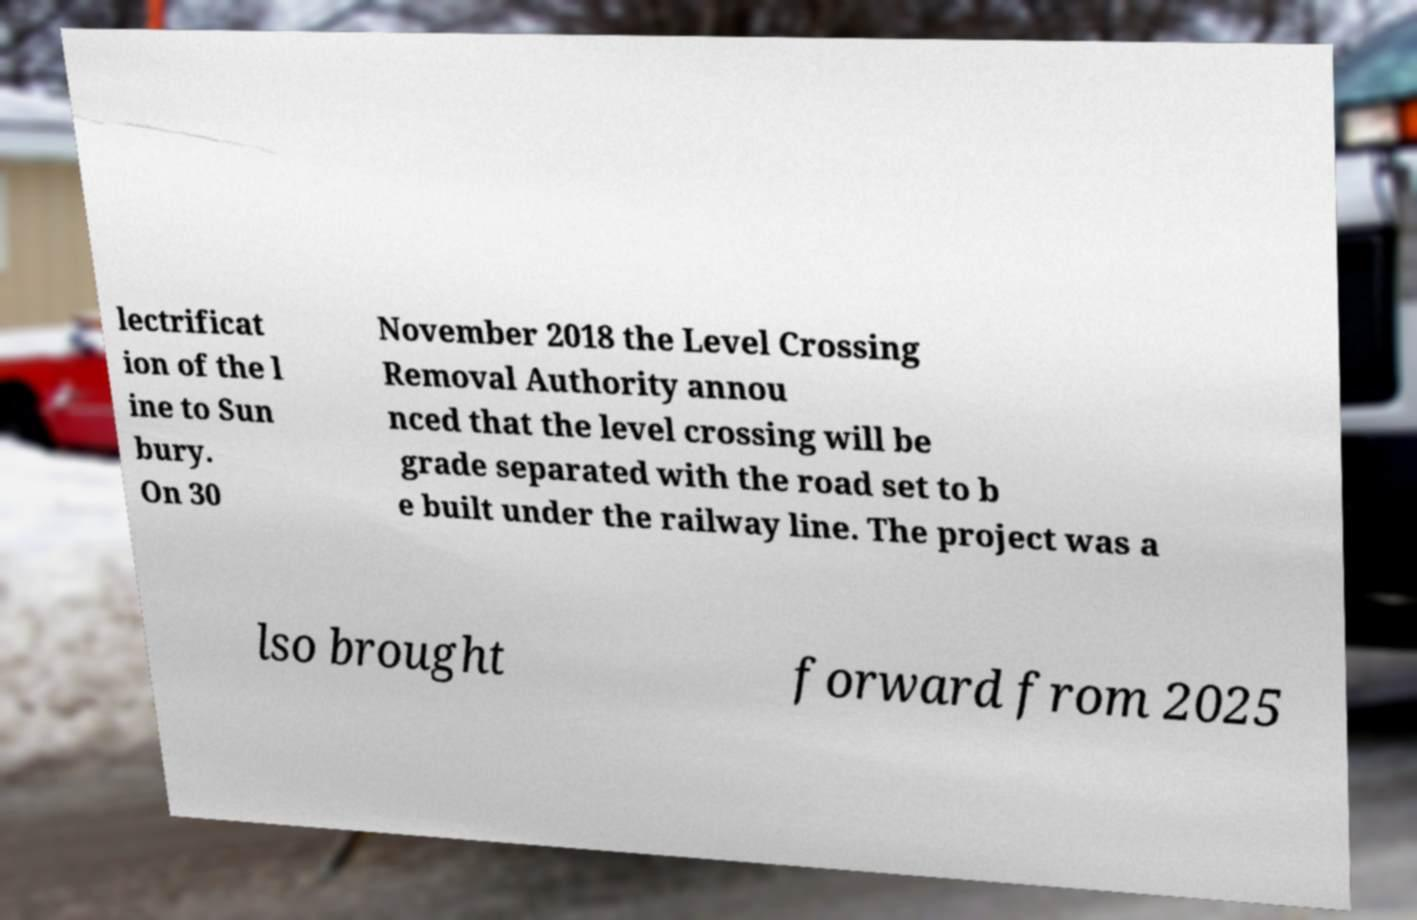What messages or text are displayed in this image? I need them in a readable, typed format. lectrificat ion of the l ine to Sun bury. On 30 November 2018 the Level Crossing Removal Authority annou nced that the level crossing will be grade separated with the road set to b e built under the railway line. The project was a lso brought forward from 2025 